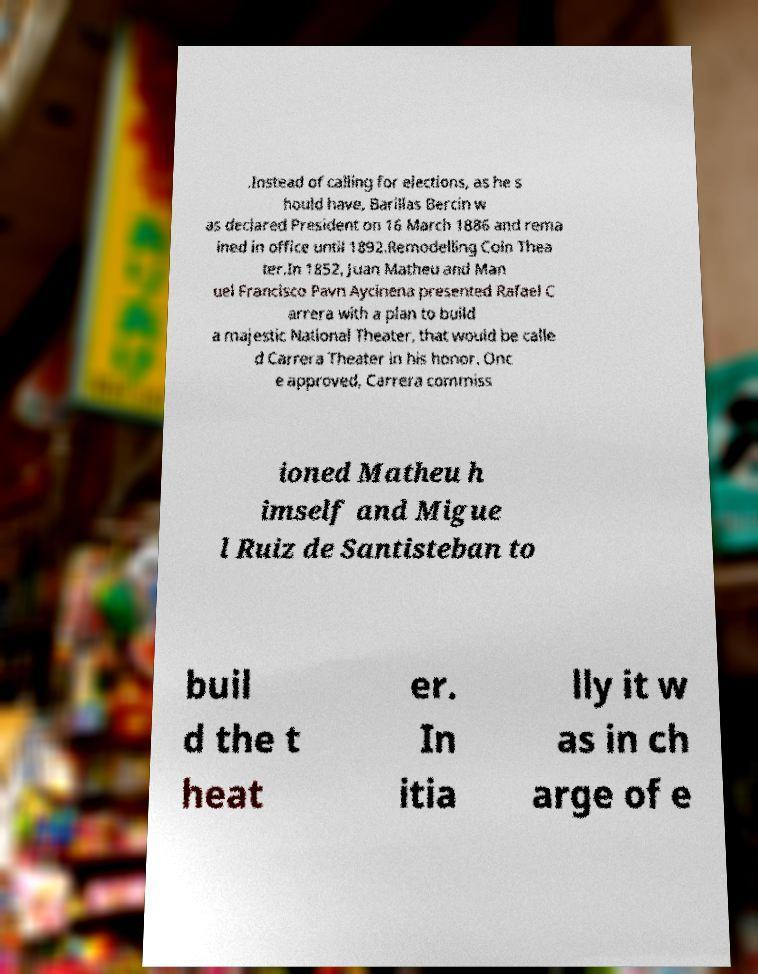For documentation purposes, I need the text within this image transcribed. Could you provide that? .Instead of calling for elections, as he s hould have, Barillas Bercin w as declared President on 16 March 1886 and rema ined in office until 1892.Remodelling Coln Thea ter.In 1852, Juan Matheu and Man uel Francisco Pavn Aycinena presented Rafael C arrera with a plan to build a majestic National Theater, that would be calle d Carrera Theater in his honor. Onc e approved, Carrera commiss ioned Matheu h imself and Migue l Ruiz de Santisteban to buil d the t heat er. In itia lly it w as in ch arge of e 